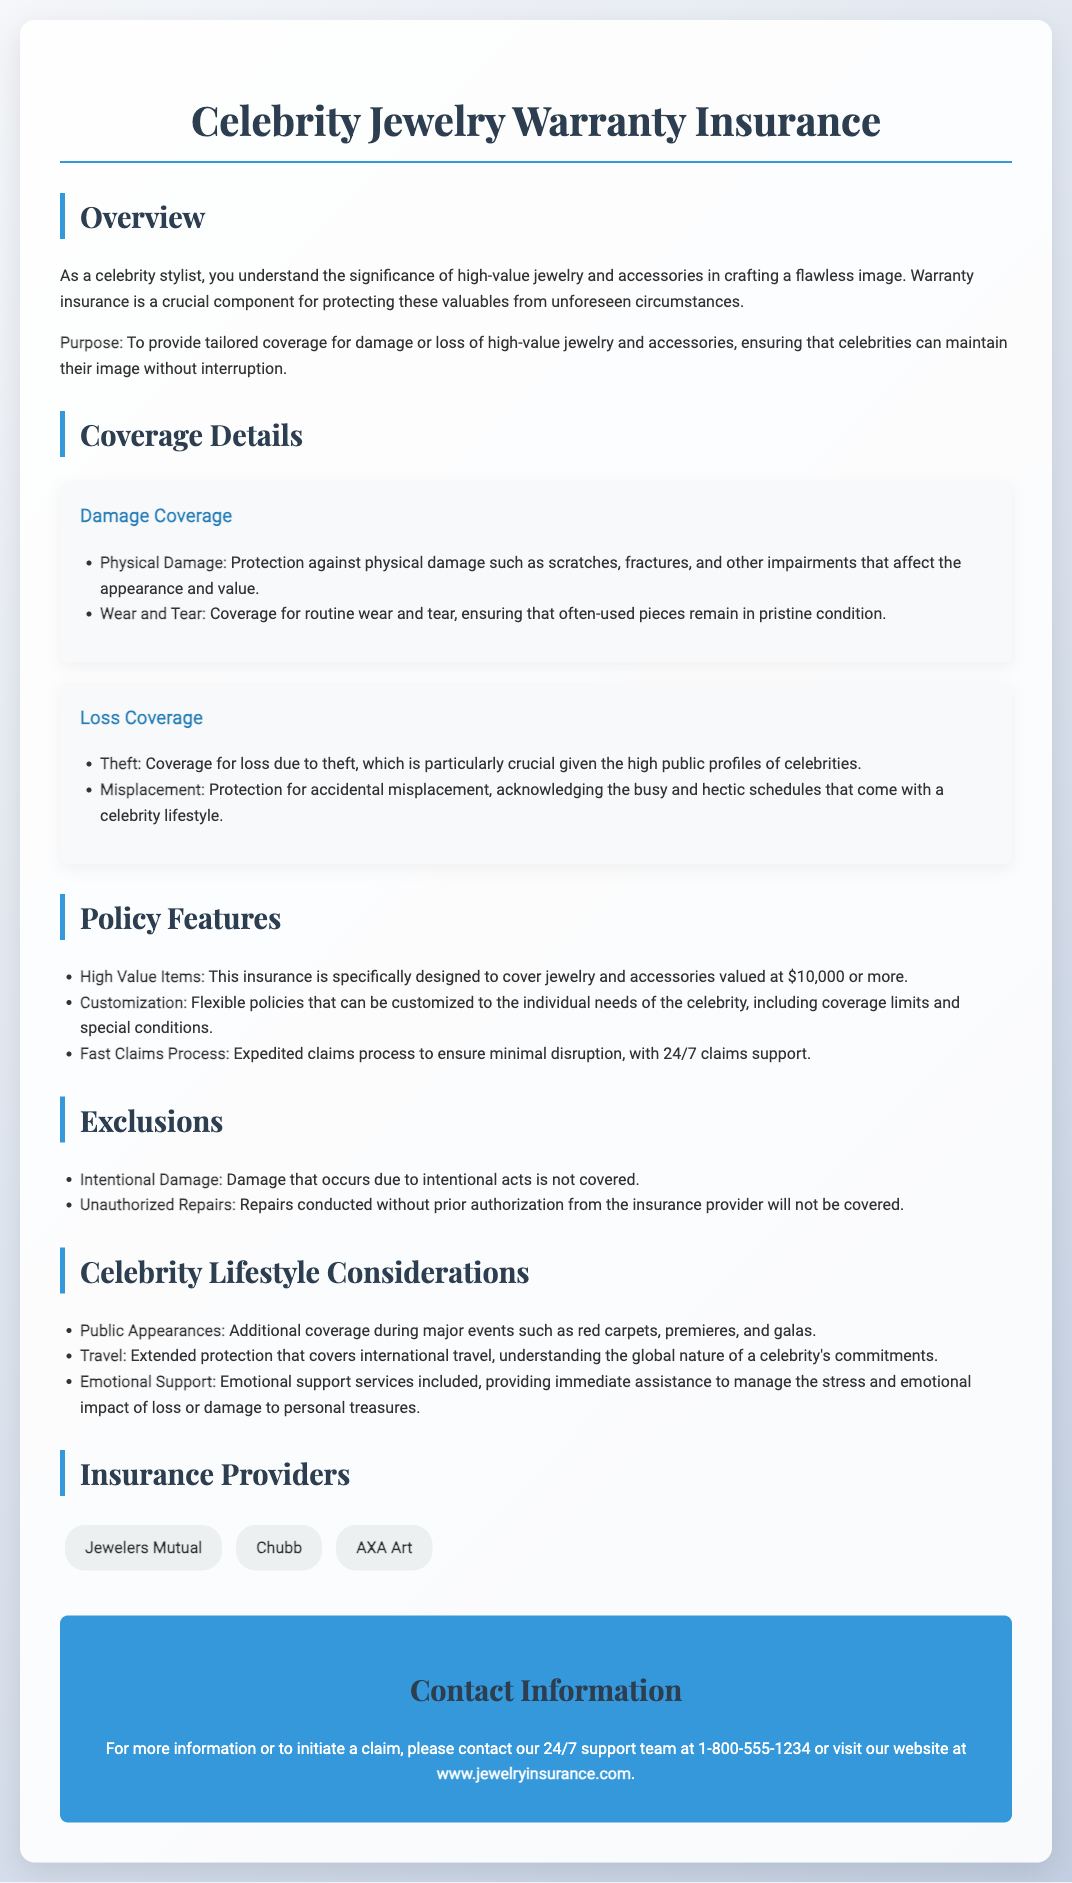What is the coverage for physical damage? The document states that coverage includes protection against physical damage such as scratches, fractures, and other impairments.
Answer: Protection against physical damage What items are specifically covered? The document mentions that this insurance is specifically designed to cover jewelry and accessories valued at $10,000 or more.
Answer: Jewelry and accessories valued at $10,000 or more Which provider is listed first? The first insurance provider mentioned in the document is Jewelers Mutual.
Answer: Jewelers Mutual What support is provided for emotional impact? The document includes emotional support services that provide immediate assistance to manage stress and emotional impact of loss or damage.
Answer: Emotional support services What type of damage is not covered? The document states that intentional damage is one type of damage that is not covered.
Answer: Intentional damage What type of claims process is emphasized? The document emphasizes a fast, expedited claims process to ensure minimal disruption.
Answer: Expedited claims process What additional coverage is mentioned for public appearances? The document mentions additional coverage during major events such as red carpets, premieres, and galas.
Answer: Additional coverage during major events What is the contact number for support? The document states that the contact number for support is 1-800-555-1234.
Answer: 1-800-555-1234 